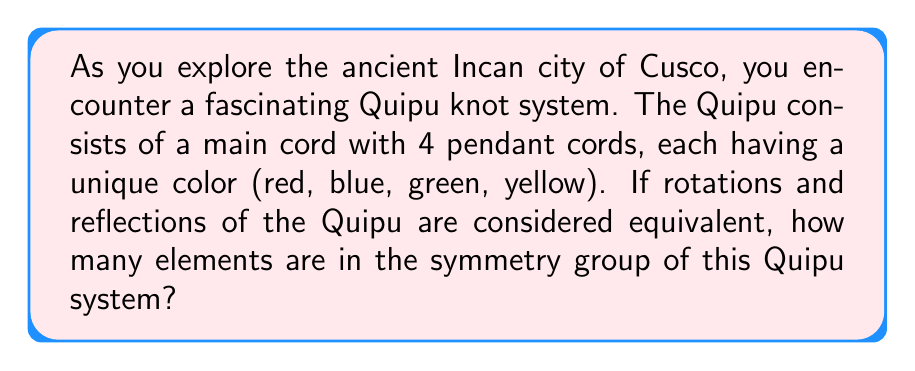Solve this math problem. Let's approach this step-by-step:

1) First, we need to understand what symmetries are possible for this Quipu system:
   - Rotations around the main cord
   - Reflections across a plane containing the main cord

2) For rotations:
   - There are 4 pendant cords, so we can rotate by 0°, 90°, 180°, and 270°
   - This gives us 4 rotational symmetries

3) For reflections:
   - We can reflect across 4 planes (each plane passing through one pendant cord and bisecting the angle between two adjacent cords)
   - This gives us 4 reflection symmetries

4) The total number of symmetries is the sum of rotational and reflection symmetries:
   $$ 4 + 4 = 8 $$

5) These 8 symmetries form a group under composition, known as the dihedral group $D_4$

6) We can verify this by listing all the elements:
   - Identity (0° rotation)
   - 90° rotation
   - 180° rotation
   - 270° rotation
   - 4 reflections

Therefore, the symmetry group of this Quipu system has 8 elements.
Answer: 8 